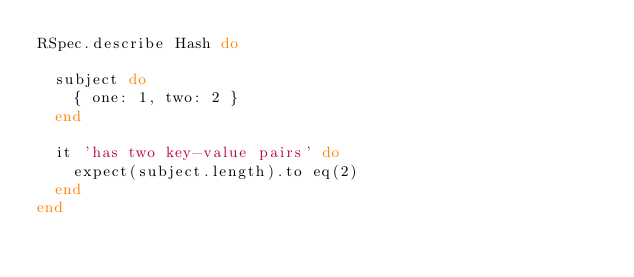<code> <loc_0><loc_0><loc_500><loc_500><_Ruby_>RSpec.describe Hash do

  subject do
    { one: 1, two: 2 }
  end

  it 'has two key-value pairs' do
    expect(subject.length).to eq(2)
  end
end</code> 